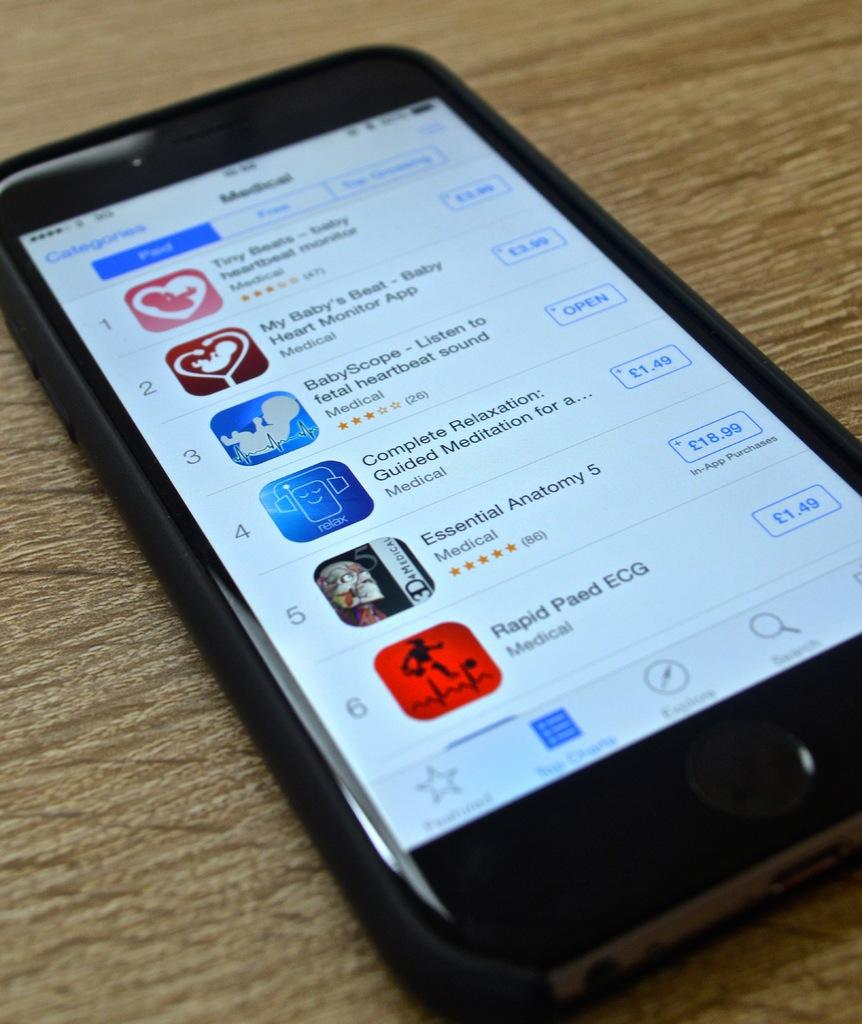<image>
Create a compact narrative representing the image presented. Apps used to hear a fetal heartbeat, such as Baby's Beat are displayed on the screen of a smart phone. 